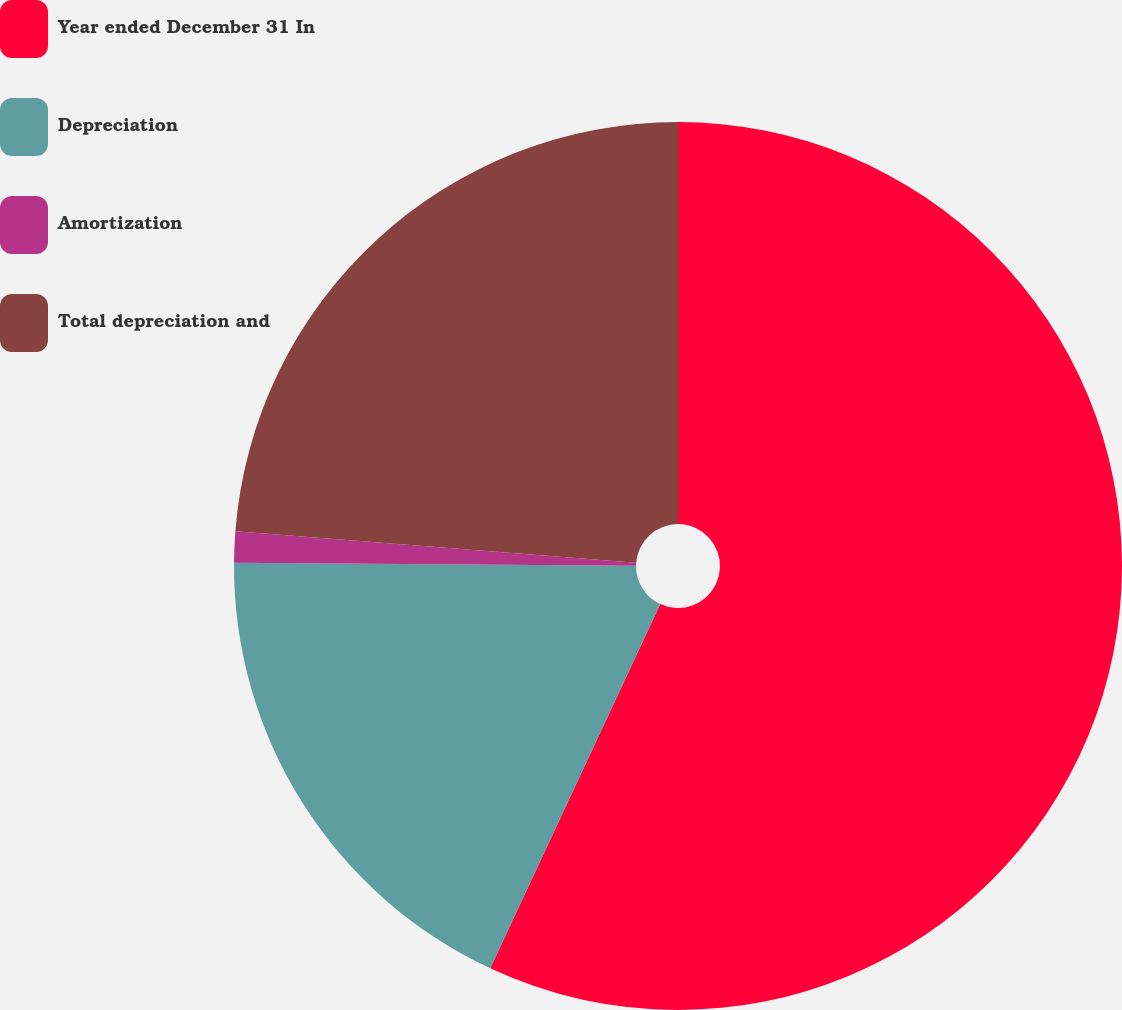<chart> <loc_0><loc_0><loc_500><loc_500><pie_chart><fcel>Year ended December 31 In<fcel>Depreciation<fcel>Amortization<fcel>Total depreciation and<nl><fcel>56.95%<fcel>18.17%<fcel>1.13%<fcel>23.75%<nl></chart> 